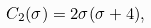<formula> <loc_0><loc_0><loc_500><loc_500>C _ { 2 } ( \sigma ) = 2 \sigma ( \sigma + 4 ) ,</formula> 